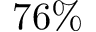<formula> <loc_0><loc_0><loc_500><loc_500>7 6 \%</formula> 